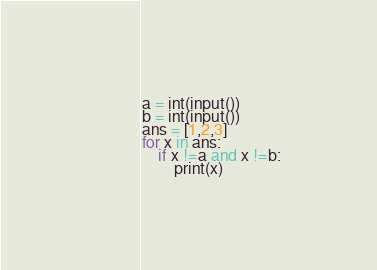Convert code to text. <code><loc_0><loc_0><loc_500><loc_500><_Python_>a = int(input())
b = int(input())
ans = [1,2,3]
for x in ans:
    if x !=a and x !=b:
        print(x)
</code> 